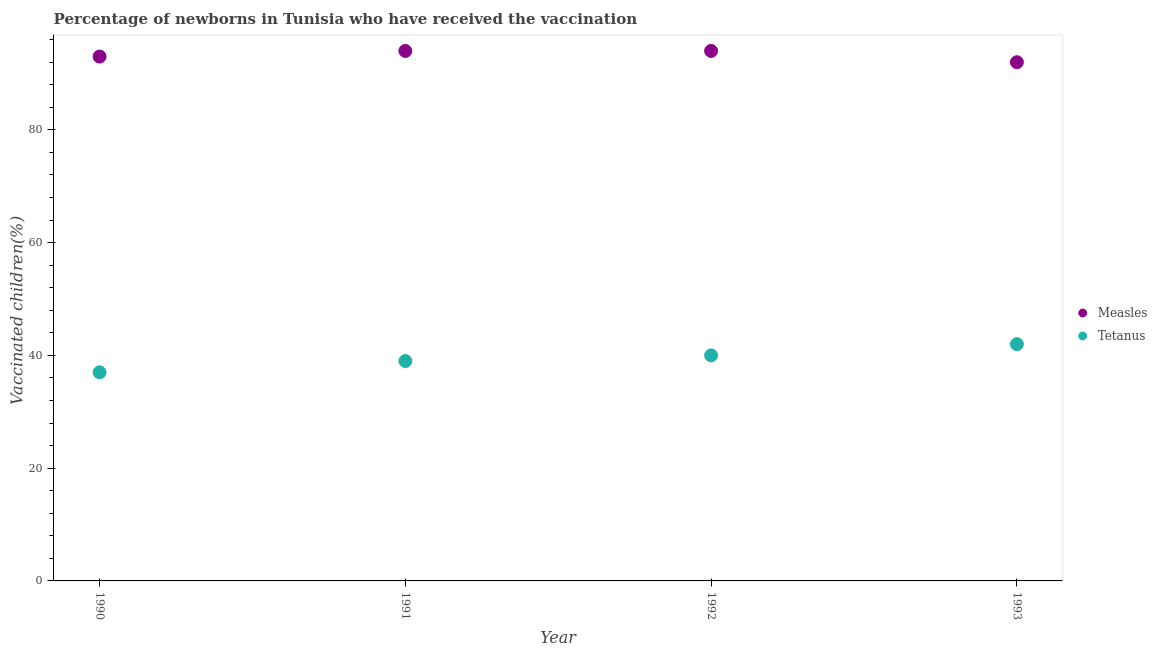How many different coloured dotlines are there?
Keep it short and to the point. 2. What is the percentage of newborns who received vaccination for tetanus in 1993?
Offer a very short reply. 42. Across all years, what is the maximum percentage of newborns who received vaccination for measles?
Make the answer very short. 94. Across all years, what is the minimum percentage of newborns who received vaccination for tetanus?
Make the answer very short. 37. In which year was the percentage of newborns who received vaccination for measles minimum?
Your answer should be compact. 1993. What is the total percentage of newborns who received vaccination for tetanus in the graph?
Your answer should be compact. 158. What is the difference between the percentage of newborns who received vaccination for measles in 1990 and that in 1993?
Keep it short and to the point. 1. What is the difference between the percentage of newborns who received vaccination for measles in 1993 and the percentage of newborns who received vaccination for tetanus in 1991?
Make the answer very short. 53. What is the average percentage of newborns who received vaccination for tetanus per year?
Your answer should be very brief. 39.5. In the year 1990, what is the difference between the percentage of newborns who received vaccination for tetanus and percentage of newborns who received vaccination for measles?
Ensure brevity in your answer.  -56. What is the ratio of the percentage of newborns who received vaccination for tetanus in 1990 to that in 1993?
Keep it short and to the point. 0.88. Is the percentage of newborns who received vaccination for measles in 1991 less than that in 1993?
Keep it short and to the point. No. Is the difference between the percentage of newborns who received vaccination for tetanus in 1991 and 1993 greater than the difference between the percentage of newborns who received vaccination for measles in 1991 and 1993?
Keep it short and to the point. No. What is the difference between the highest and the lowest percentage of newborns who received vaccination for measles?
Your answer should be very brief. 2. In how many years, is the percentage of newborns who received vaccination for tetanus greater than the average percentage of newborns who received vaccination for tetanus taken over all years?
Offer a very short reply. 2. Does the percentage of newborns who received vaccination for measles monotonically increase over the years?
Your response must be concise. No. Is the percentage of newborns who received vaccination for tetanus strictly greater than the percentage of newborns who received vaccination for measles over the years?
Your response must be concise. No. Is the percentage of newborns who received vaccination for measles strictly less than the percentage of newborns who received vaccination for tetanus over the years?
Offer a very short reply. No. How many dotlines are there?
Your answer should be compact. 2. Are the values on the major ticks of Y-axis written in scientific E-notation?
Your response must be concise. No. Does the graph contain any zero values?
Keep it short and to the point. No. Where does the legend appear in the graph?
Offer a terse response. Center right. How many legend labels are there?
Offer a very short reply. 2. What is the title of the graph?
Provide a short and direct response. Percentage of newborns in Tunisia who have received the vaccination. What is the label or title of the Y-axis?
Your response must be concise. Vaccinated children(%)
. What is the Vaccinated children(%)
 of Measles in 1990?
Make the answer very short. 93. What is the Vaccinated children(%)
 of Measles in 1991?
Keep it short and to the point. 94. What is the Vaccinated children(%)
 of Tetanus in 1991?
Your answer should be very brief. 39. What is the Vaccinated children(%)
 in Measles in 1992?
Ensure brevity in your answer.  94. What is the Vaccinated children(%)
 of Tetanus in 1992?
Provide a short and direct response. 40. What is the Vaccinated children(%)
 of Measles in 1993?
Your response must be concise. 92. What is the Vaccinated children(%)
 in Tetanus in 1993?
Your answer should be compact. 42. Across all years, what is the maximum Vaccinated children(%)
 of Measles?
Offer a very short reply. 94. Across all years, what is the minimum Vaccinated children(%)
 in Measles?
Offer a very short reply. 92. Across all years, what is the minimum Vaccinated children(%)
 of Tetanus?
Ensure brevity in your answer.  37. What is the total Vaccinated children(%)
 of Measles in the graph?
Offer a very short reply. 373. What is the total Vaccinated children(%)
 of Tetanus in the graph?
Provide a succinct answer. 158. What is the difference between the Vaccinated children(%)
 in Measles in 1990 and that in 1991?
Give a very brief answer. -1. What is the difference between the Vaccinated children(%)
 of Tetanus in 1990 and that in 1991?
Make the answer very short. -2. What is the difference between the Vaccinated children(%)
 in Tetanus in 1990 and that in 1992?
Ensure brevity in your answer.  -3. What is the difference between the Vaccinated children(%)
 of Measles in 1990 and that in 1993?
Keep it short and to the point. 1. What is the difference between the Vaccinated children(%)
 in Tetanus in 1990 and that in 1993?
Provide a succinct answer. -5. What is the difference between the Vaccinated children(%)
 in Measles in 1991 and that in 1993?
Offer a very short reply. 2. What is the difference between the Vaccinated children(%)
 of Tetanus in 1991 and that in 1993?
Offer a terse response. -3. What is the difference between the Vaccinated children(%)
 in Measles in 1992 and that in 1993?
Ensure brevity in your answer.  2. What is the difference between the Vaccinated children(%)
 in Tetanus in 1992 and that in 1993?
Provide a short and direct response. -2. What is the difference between the Vaccinated children(%)
 of Measles in 1991 and the Vaccinated children(%)
 of Tetanus in 1992?
Your answer should be very brief. 54. What is the difference between the Vaccinated children(%)
 of Measles in 1991 and the Vaccinated children(%)
 of Tetanus in 1993?
Your answer should be compact. 52. What is the difference between the Vaccinated children(%)
 of Measles in 1992 and the Vaccinated children(%)
 of Tetanus in 1993?
Provide a succinct answer. 52. What is the average Vaccinated children(%)
 of Measles per year?
Provide a succinct answer. 93.25. What is the average Vaccinated children(%)
 of Tetanus per year?
Your answer should be very brief. 39.5. In the year 1991, what is the difference between the Vaccinated children(%)
 of Measles and Vaccinated children(%)
 of Tetanus?
Provide a short and direct response. 55. In the year 1992, what is the difference between the Vaccinated children(%)
 in Measles and Vaccinated children(%)
 in Tetanus?
Your response must be concise. 54. In the year 1993, what is the difference between the Vaccinated children(%)
 of Measles and Vaccinated children(%)
 of Tetanus?
Ensure brevity in your answer.  50. What is the ratio of the Vaccinated children(%)
 of Measles in 1990 to that in 1991?
Offer a terse response. 0.99. What is the ratio of the Vaccinated children(%)
 in Tetanus in 1990 to that in 1991?
Provide a succinct answer. 0.95. What is the ratio of the Vaccinated children(%)
 in Tetanus in 1990 to that in 1992?
Make the answer very short. 0.93. What is the ratio of the Vaccinated children(%)
 in Measles in 1990 to that in 1993?
Provide a succinct answer. 1.01. What is the ratio of the Vaccinated children(%)
 of Tetanus in 1990 to that in 1993?
Provide a short and direct response. 0.88. What is the ratio of the Vaccinated children(%)
 of Measles in 1991 to that in 1992?
Provide a succinct answer. 1. What is the ratio of the Vaccinated children(%)
 of Tetanus in 1991 to that in 1992?
Your response must be concise. 0.97. What is the ratio of the Vaccinated children(%)
 in Measles in 1991 to that in 1993?
Ensure brevity in your answer.  1.02. What is the ratio of the Vaccinated children(%)
 of Measles in 1992 to that in 1993?
Keep it short and to the point. 1.02. What is the difference between the highest and the lowest Vaccinated children(%)
 in Measles?
Make the answer very short. 2. 